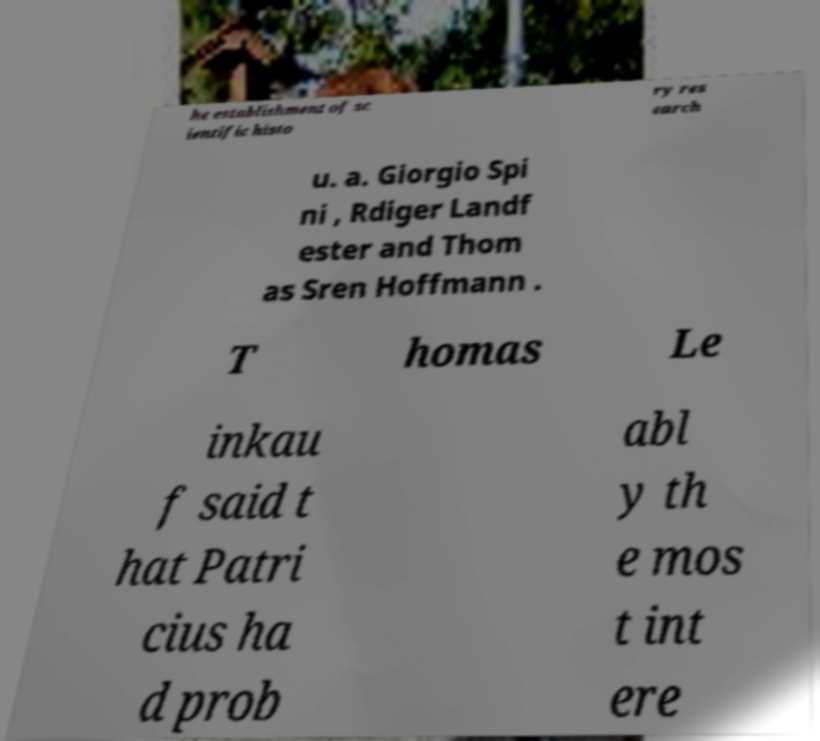There's text embedded in this image that I need extracted. Can you transcribe it verbatim? he establishment of sc ientific histo ry res earch u. a. Giorgio Spi ni , Rdiger Landf ester and Thom as Sren Hoffmann . T homas Le inkau f said t hat Patri cius ha d prob abl y th e mos t int ere 